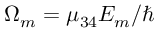<formula> <loc_0><loc_0><loc_500><loc_500>{ \Omega _ { m } } = { \mu _ { 3 4 } } { E _ { m } } / \hbar</formula> 